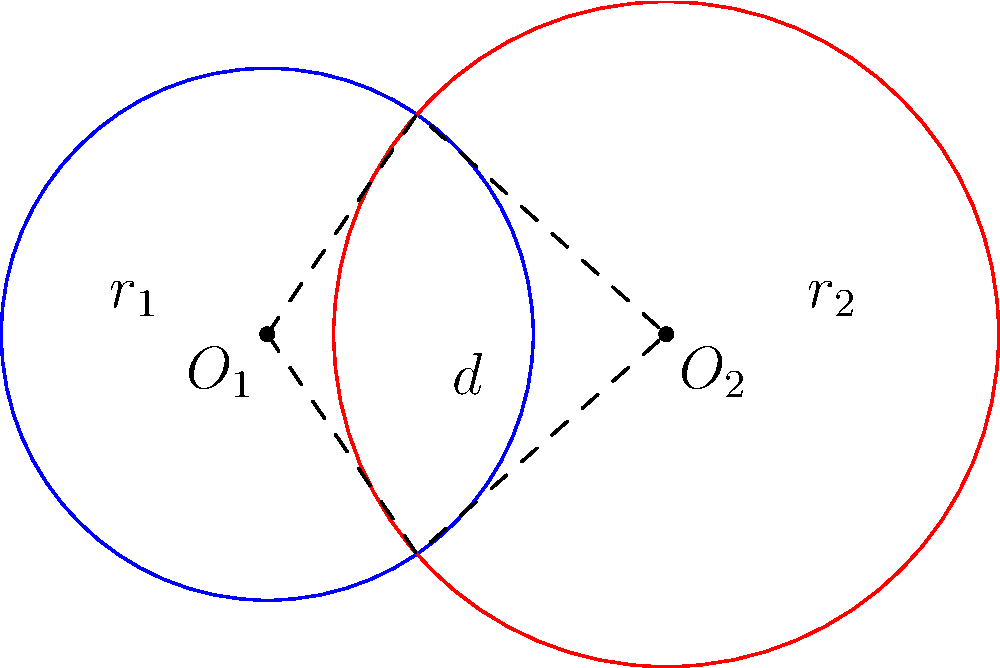Two circular surveillance zones are set up to monitor potential criminal activity. The first zone, centered at $O_1$, has a radius of 2 km, while the second zone, centered at $O_2$, has a radius of 2.5 km. The centers of these zones are 3 km apart. Calculate the area of the region where the two surveillance zones overlap, rounded to two decimal places. To solve this problem, we'll use the formula for the area of intersection of two circles:

$$A = r_1^2 \arccos(\frac{d^2 + r_1^2 - r_2^2}{2dr_1}) + r_2^2 \arccos(\frac{d^2 + r_2^2 - r_1^2}{2dr_2}) - \frac{1}{2}\sqrt{(-d+r_1+r_2)(d+r_1-r_2)(d-r_1+r_2)(d+r_1+r_2)}$$

Where:
$r_1 = 2$ km (radius of first circle)
$r_2 = 2.5$ km (radius of second circle)
$d = 3$ km (distance between centers)

Step 1: Calculate the first arccos term:
$$\arccos(\frac{3^2 + 2^2 - 2.5^2}{2 \cdot 3 \cdot 2}) = \arccos(0.3958) = 1.1659$$

Step 2: Calculate the second arccos term:
$$\arccos(\frac{3^2 + 2.5^2 - 2^2}{2 \cdot 3 \cdot 2.5}) = \arccos(0.5167) = 1.0247$$

Step 3: Calculate the square root term:
$$\sqrt{(-3+2+2.5)(3+2-2.5)(3-2+2.5)(3+2+2.5)} = 3.7749$$

Step 4: Put it all together:
$$A = 2^2 \cdot 1.1659 + 2.5^2 \cdot 1.0247 - \frac{1}{2} \cdot 3.7749$$
$$A = 4.6636 + 6.4044 - 1.8875 = 9.1805$$

Step 5: Round to two decimal places:
$$A \approx 9.18 \text{ km}^2$$
Answer: 9.18 km² 